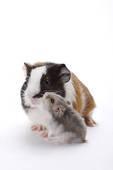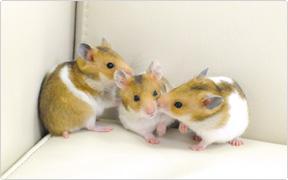The first image is the image on the left, the second image is the image on the right. For the images displayed, is the sentence "One rodent sits alone in the image on the right." factually correct? Answer yes or no. No. 